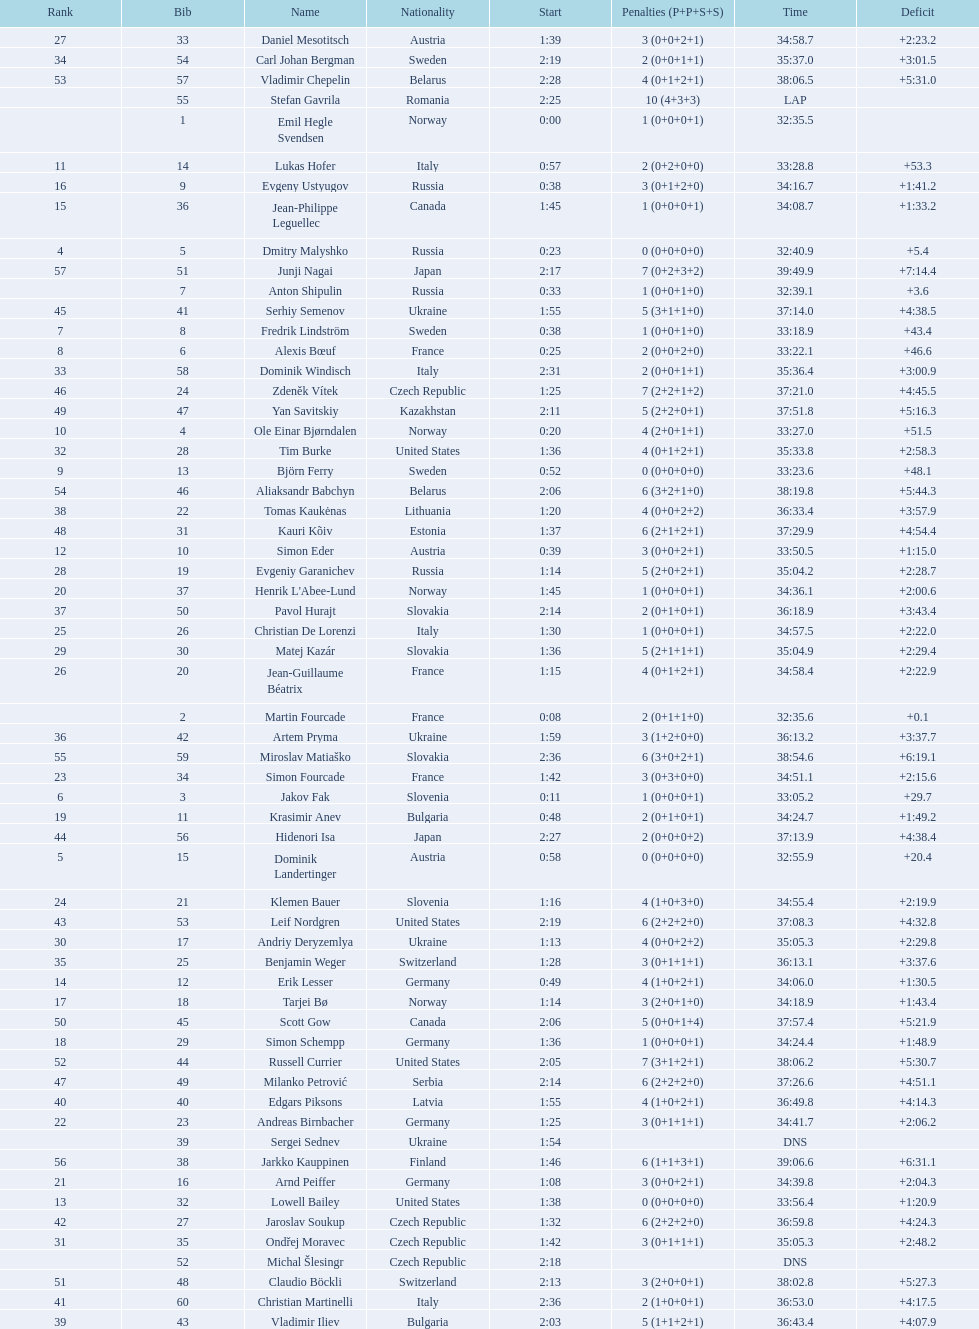How many took at least 35:00 to finish? 30. 